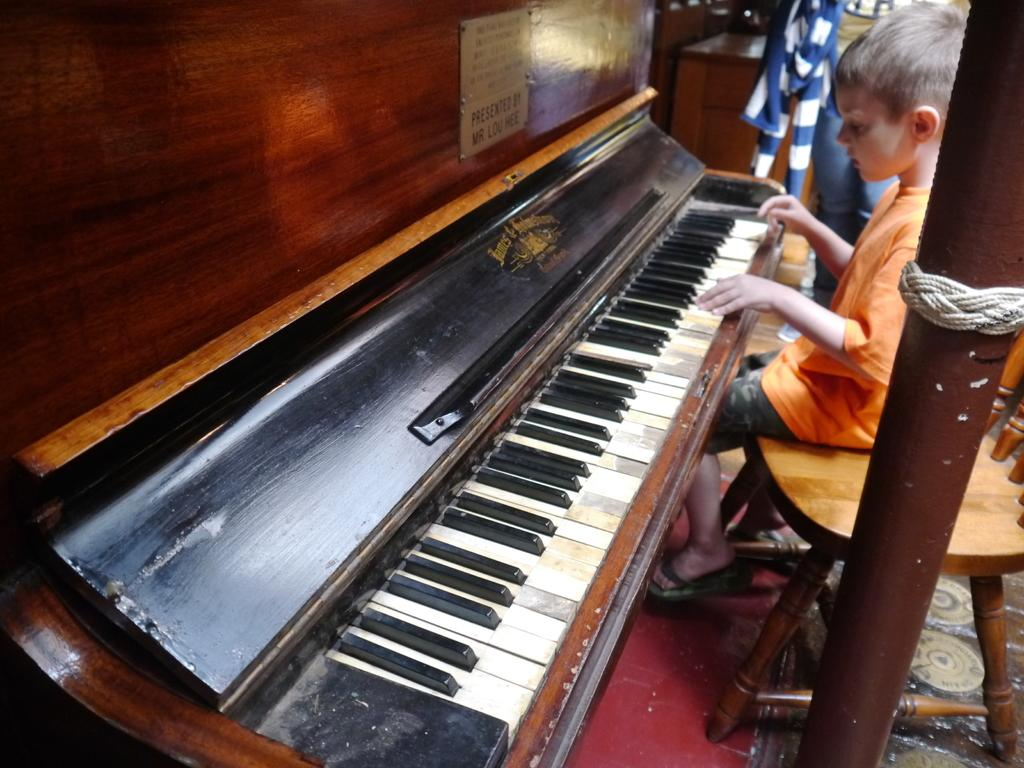What is the main subject of the image? The main subject of the image is a kid. What is the kid doing in the image? The kid is playing a piano. What type of bells can be heard ringing in the image? There are no bells present in the image, and therefore no sound can be heard. What is the exchange rate between two currencies in the image? There is no reference to currency exchange or rates in the image. 